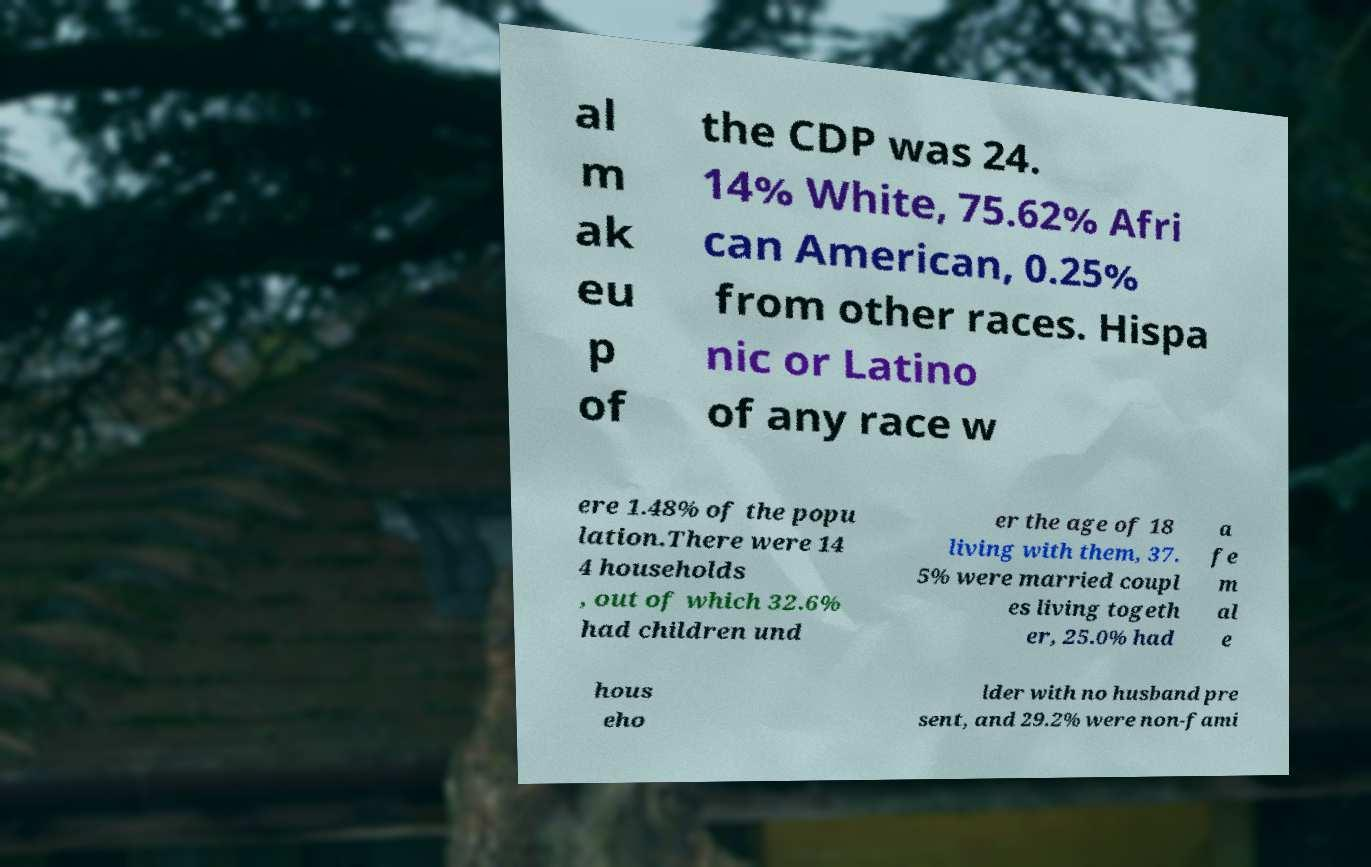For documentation purposes, I need the text within this image transcribed. Could you provide that? al m ak eu p of the CDP was 24. 14% White, 75.62% Afri can American, 0.25% from other races. Hispa nic or Latino of any race w ere 1.48% of the popu lation.There were 14 4 households , out of which 32.6% had children und er the age of 18 living with them, 37. 5% were married coupl es living togeth er, 25.0% had a fe m al e hous eho lder with no husband pre sent, and 29.2% were non-fami 